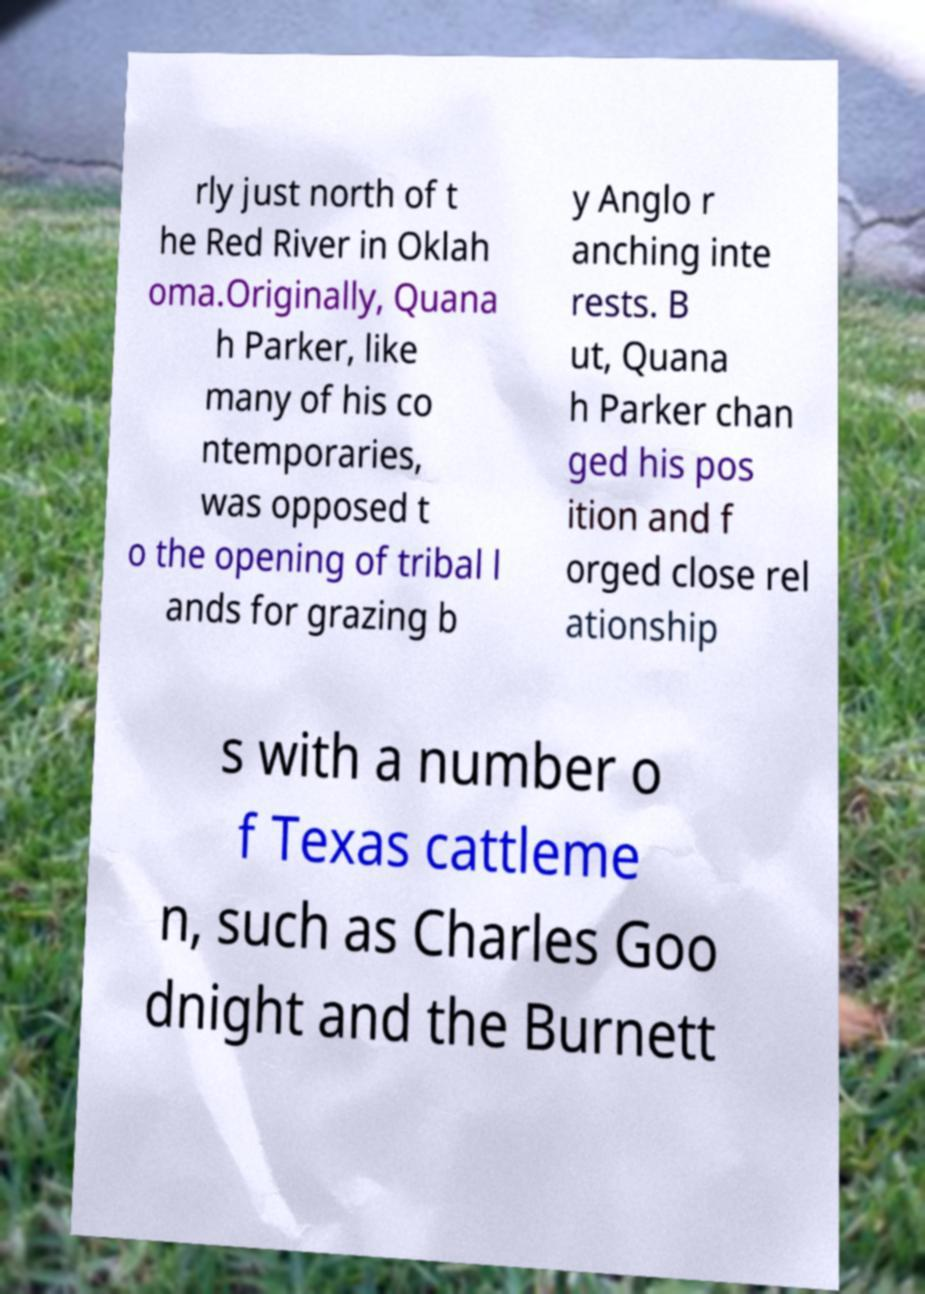There's text embedded in this image that I need extracted. Can you transcribe it verbatim? rly just north of t he Red River in Oklah oma.Originally, Quana h Parker, like many of his co ntemporaries, was opposed t o the opening of tribal l ands for grazing b y Anglo r anching inte rests. B ut, Quana h Parker chan ged his pos ition and f orged close rel ationship s with a number o f Texas cattleme n, such as Charles Goo dnight and the Burnett 